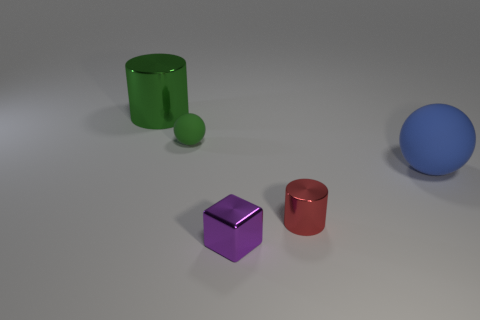What is the object that is on the right side of the purple metallic block and on the left side of the large ball made of?
Offer a terse response. Metal. What shape is the purple metal thing that is the same size as the green sphere?
Give a very brief answer. Cube. There is a cylinder that is in front of the rubber sphere on the right side of the green object in front of the big metal object; what color is it?
Ensure brevity in your answer.  Red. What number of things are either metal cylinders in front of the green metal cylinder or big yellow rubber cubes?
Keep it short and to the point. 1. What material is the purple thing that is the same size as the red metal object?
Provide a succinct answer. Metal. What is the material of the green object that is right of the metal cylinder behind the rubber ball to the left of the large blue object?
Provide a short and direct response. Rubber. The big rubber sphere has what color?
Make the answer very short. Blue. What number of tiny objects are either green metal cylinders or metal things?
Offer a terse response. 2. What is the material of the cylinder that is the same color as the small sphere?
Provide a succinct answer. Metal. Do the green thing that is on the right side of the large cylinder and the cylinder in front of the big green cylinder have the same material?
Provide a short and direct response. No. 